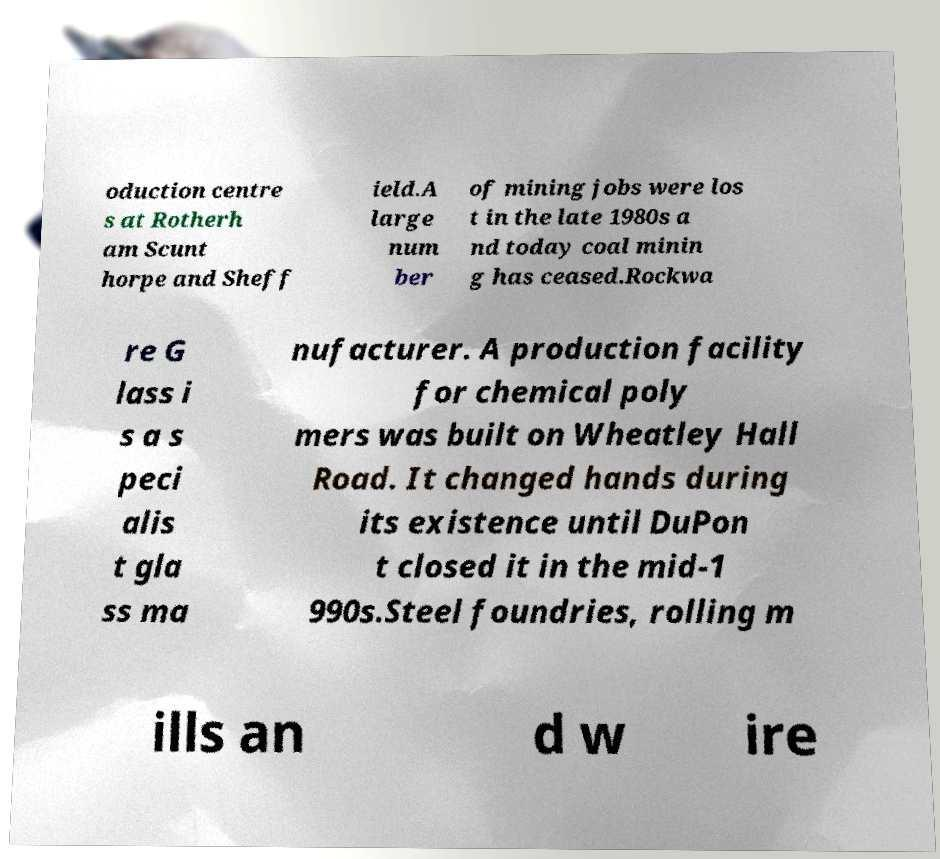Please read and relay the text visible in this image. What does it say? oduction centre s at Rotherh am Scunt horpe and Sheff ield.A large num ber of mining jobs were los t in the late 1980s a nd today coal minin g has ceased.Rockwa re G lass i s a s peci alis t gla ss ma nufacturer. A production facility for chemical poly mers was built on Wheatley Hall Road. It changed hands during its existence until DuPon t closed it in the mid-1 990s.Steel foundries, rolling m ills an d w ire 